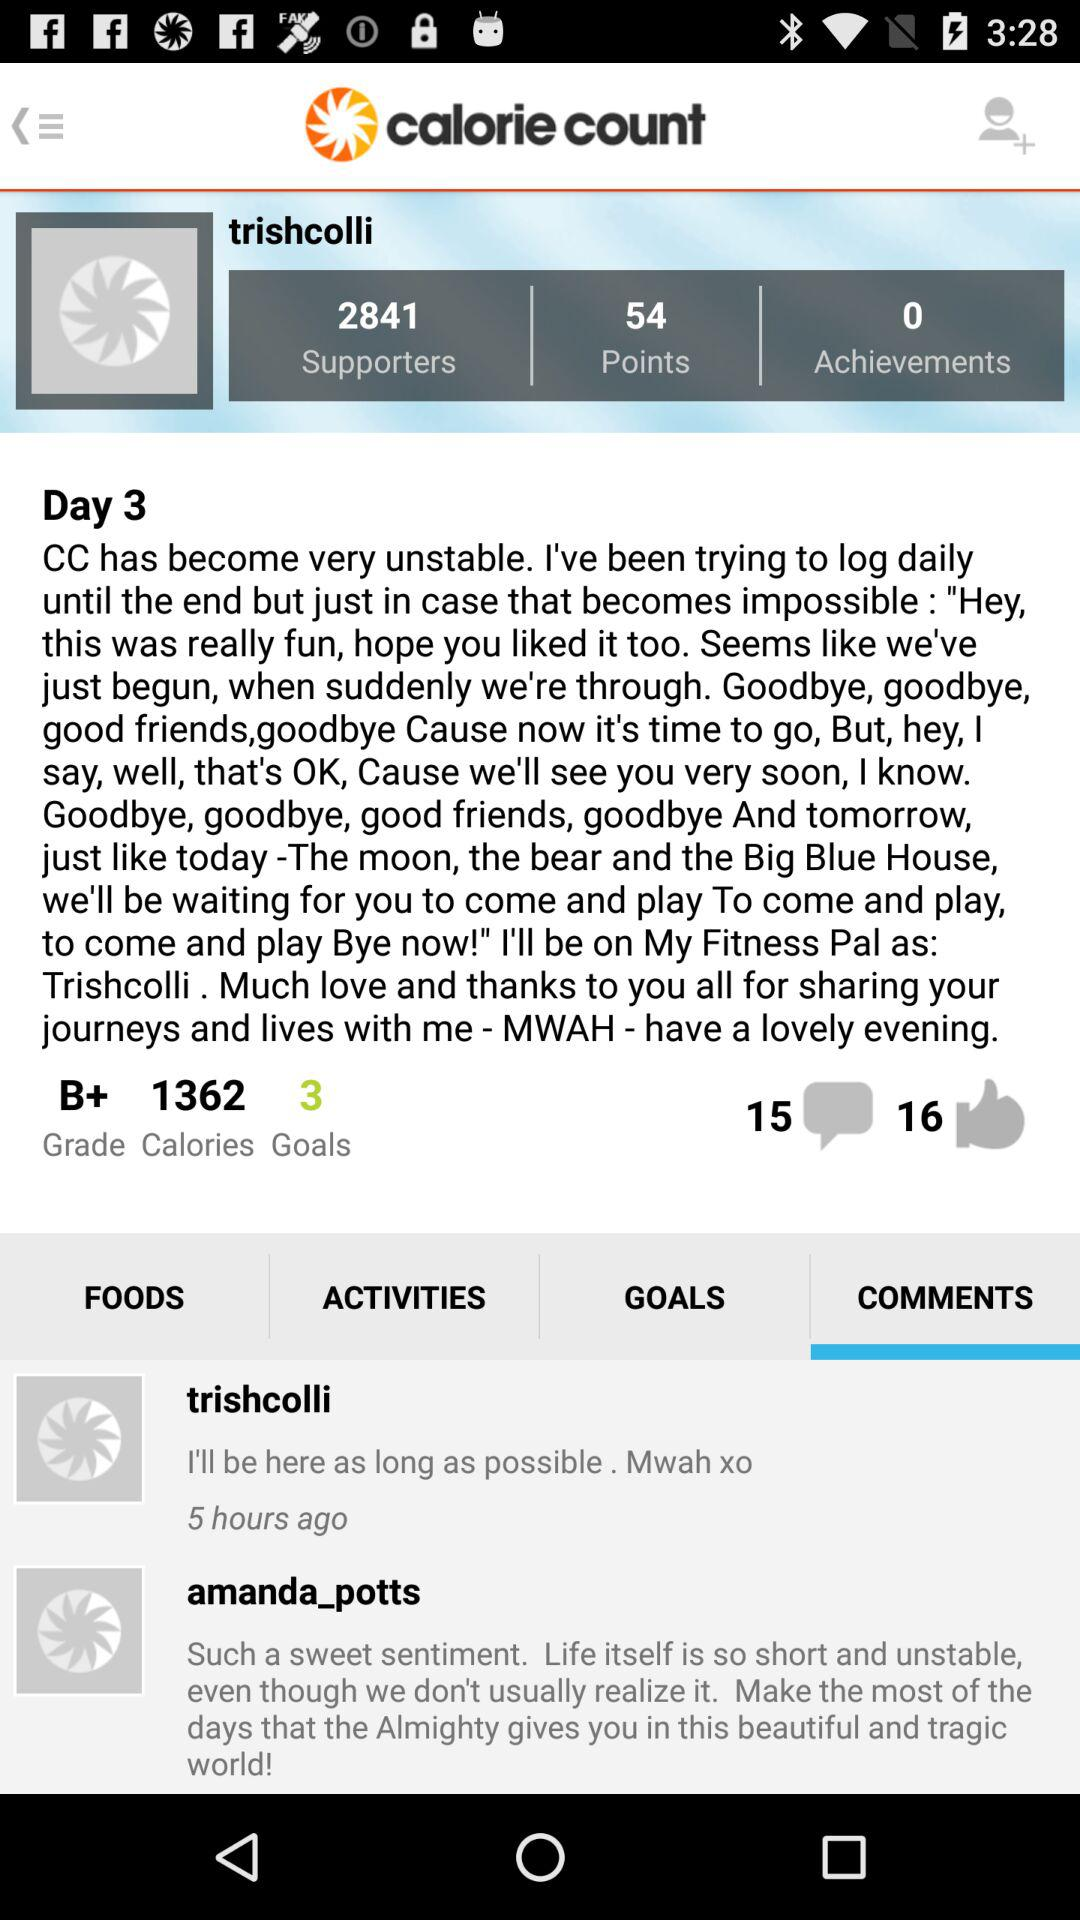How many hours ago did trishcolli post?
Answer the question using a single word or phrase. 5 